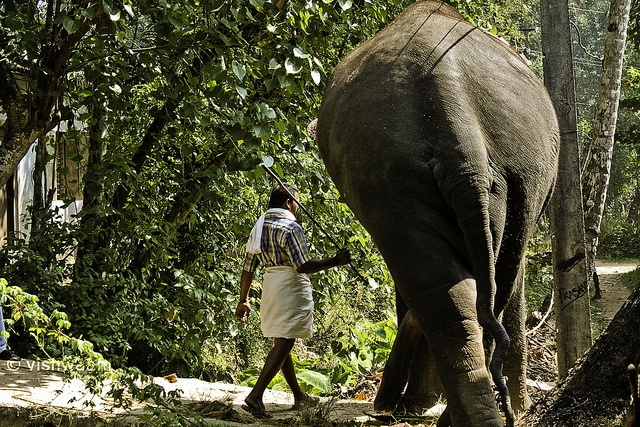Describe the objects in this image and their specific colors. I can see elephant in black, tan, and gray tones and people in black, tan, olive, and darkgray tones in this image. 